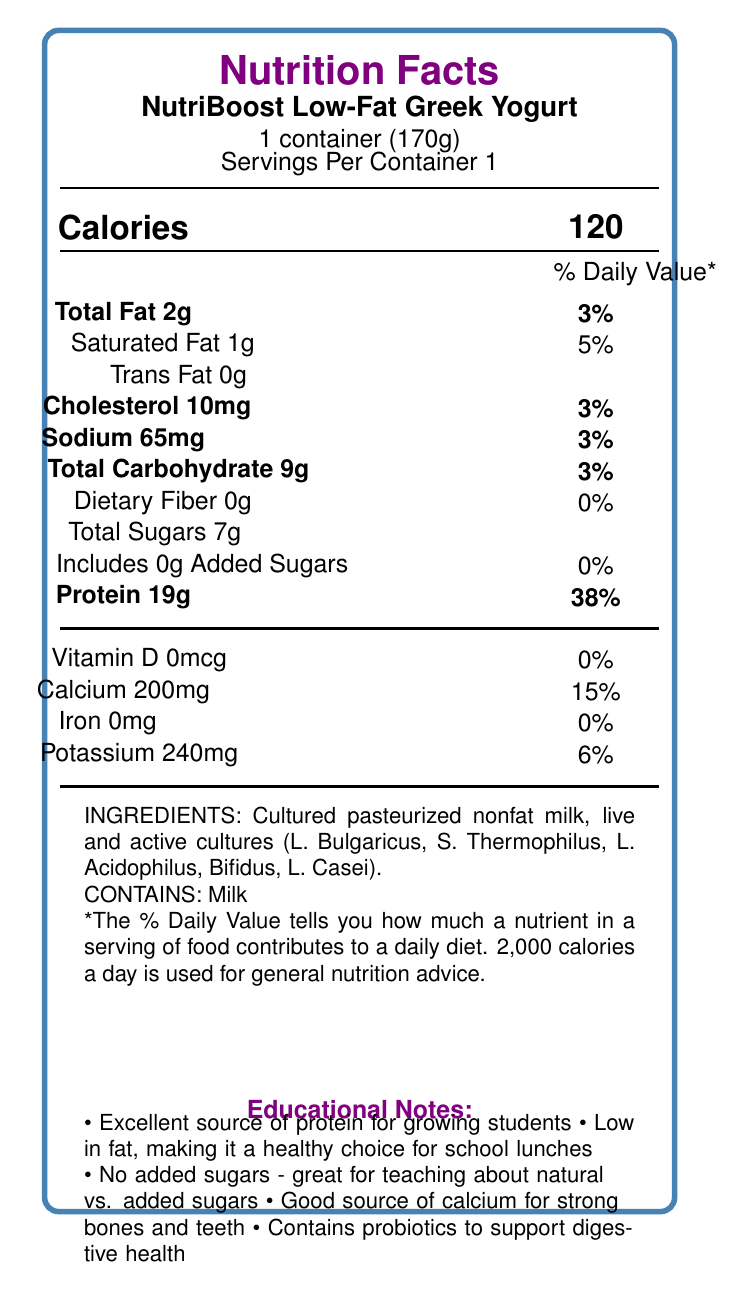How many grams of protein does the NutriBoost Low-Fat Greek Yogurt contain per serving? The document states that each container has 19 grams of protein.
Answer: 19g What percentage of the daily value of calcium does one serving provide? The calcium content for one serving is 200mg, which represents 15% of the daily value.
Answer: 15% Does the NutriBoost Low-Fat Greek Yogurt contain any added sugars? The document specifies that there are 0 grams of added sugars.
Answer: No Is the NutriBoost Low-Fat Greek Yogurt a good source of dietary fiber? The document indicates that the dietary fiber content is 0 grams, providing 0% of the daily value.
Answer: No List one health benefit of the probiotics in NutriBoost Low-Fat Greek Yogurt? The educational notes mention that the yogurt contains probiotics to support digestive health.
Answer: Supports digestive health What is the total fat content of the NutriBoost Low-Fat Greek Yogurt? The document states that the total fat content per serving is 2 grams.
Answer: 2g How much potassium is in one serving of the yogurt? The document states that the potassium content is 240mg per serving.
Answer: 240mg Which vitamin has a daily value percentage of 0% in NutriBoost Low-Fat Greek Yogurt? A. Vitamin D B. Calcium C. Iron The document shows that Vitamin D content is 0mcg, which is 0% of the daily value.
Answer: A What percentage of daily protein intake does one serving of NutriBoost Low-Fat Greek Yogurt provide? A. 15% B. 25% C. 38% D. 50% The document specifies that the protein content represents 38% of the daily value.
Answer: C Is NutriBoost Low-Fat Greek Yogurt suitable for individuals with milk allergies? The allergen information states that the product contains milk.
Answer: No Based on the Nutrition Facts Label, briefly summarize why NutriBoost Low-Fat Greek Yogurt is a suitable choice for school lunches. NutriBoost Low-Fat Greek Yogurt is highlighted as being low in fat and high in protein, an excellent source of calcium, and free from added sugars. It also contains probiotics, making it beneficial for digestive health, which makes it an excellent nutritional choice for school-aged children.
Answer: NutriBoost Low-Fat Greek Yogurt is a healthy option for school lunches due to its high protein content (19g per serving), low-fat content (2g total, including 1g saturated fat), lack of added sugars, and significant calcium (200mg) and potassium (240mg) content. Additionally, it contains probiotics, which support digestive health. How much cholesterol is in a serving of NutriBoost Low-Fat Greek Yogurt? The document states that a serving contains 10mg of cholesterol.
Answer: 10mg Can you determine the sugar content from the natural sugar in the yogurt? The document only provides the total sugars content (7g) but does not specify the amount of natural sugar versus added sugar beyond stating that added sugars are 0g.
Answer: No, it cannot be determined. The iron content in NutriBoost Low-Fat Greek Yogurt is: A. 0mg B. 0.5mg C. 5mg D. 10mg The document specifies that the iron content is 0mg.
Answer: A What are the live and active cultures present in NutriBoost Low-Fat Greek Yogurt? The ingredients list in the document includes these specific live and active cultures.
Answer: L. Bulgaricus, S. Thermophilus, L. Acidophilus, Bifidus, L. Casei 